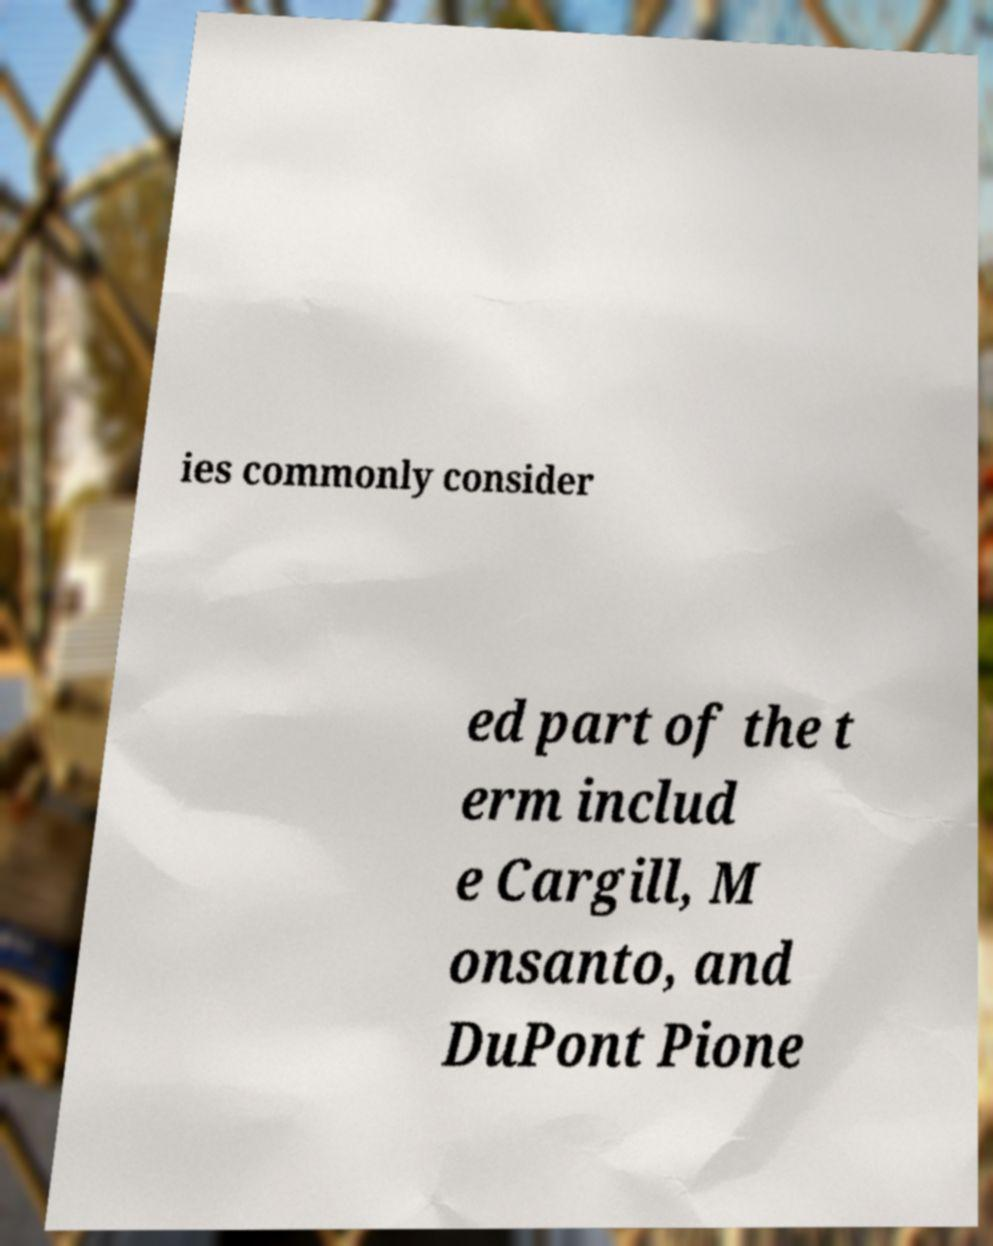For documentation purposes, I need the text within this image transcribed. Could you provide that? ies commonly consider ed part of the t erm includ e Cargill, M onsanto, and DuPont Pione 